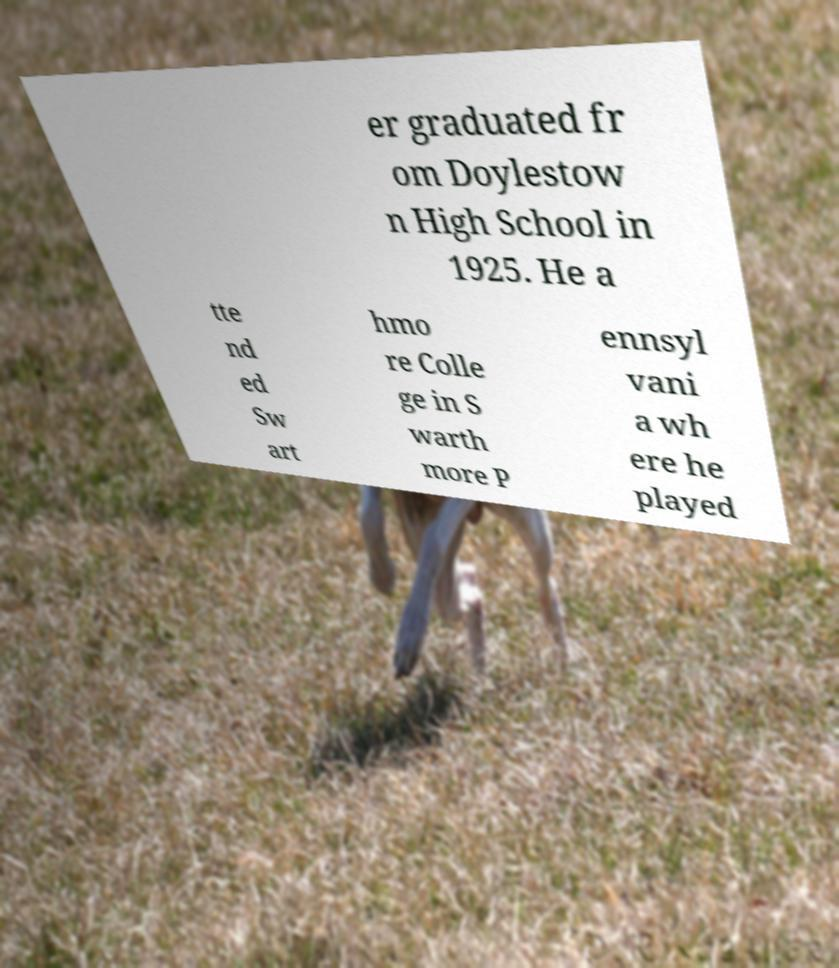I need the written content from this picture converted into text. Can you do that? er graduated fr om Doylestow n High School in 1925. He a tte nd ed Sw art hmo re Colle ge in S warth more P ennsyl vani a wh ere he played 